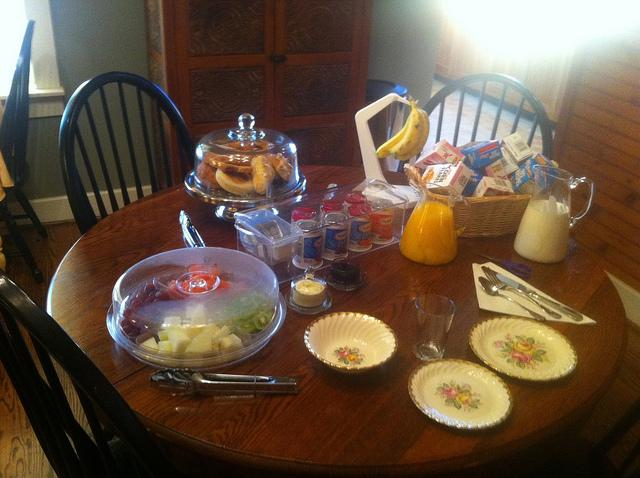What are the plastic lids used for when covering these trays of food? Please explain your reasoning. protection. The lids can protect from flies. 